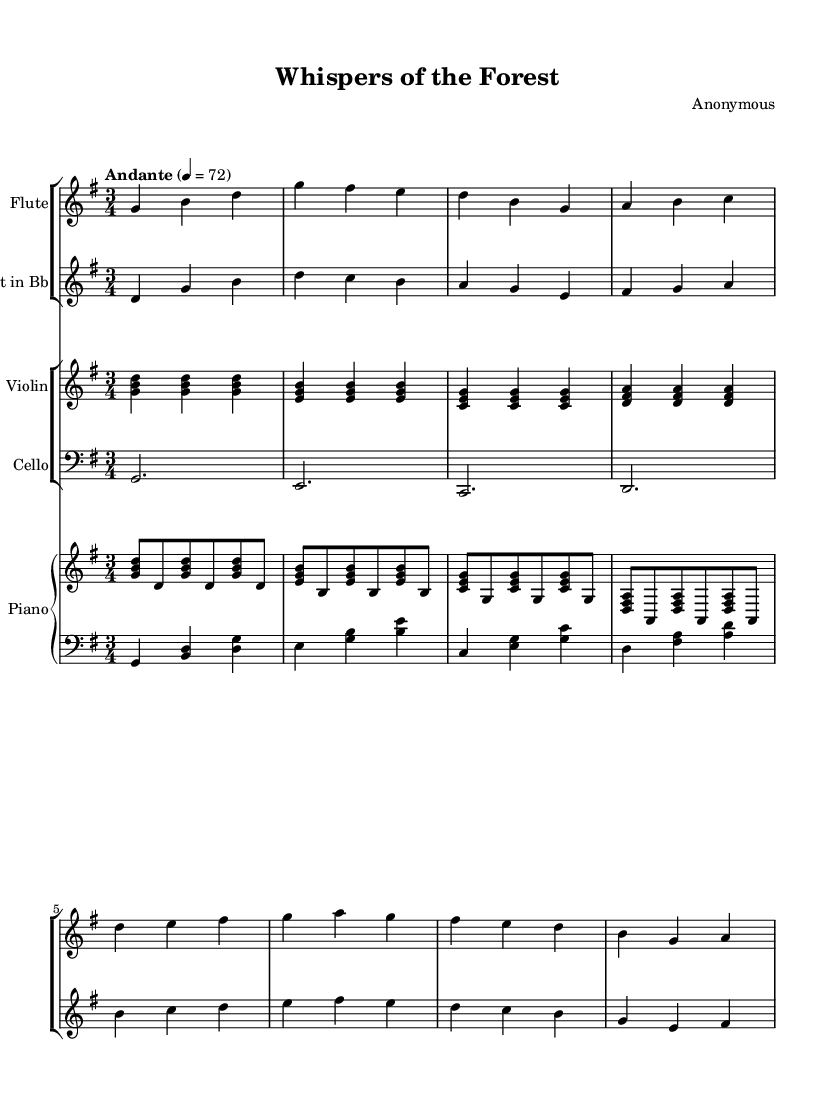What is the key signature of this music? The key signature is G major, which has one sharp (F#). This can be determined from the key signature indicated at the beginning of the piece.
Answer: G major What is the time signature of this music? The time signature is 3/4, as indicated at the beginning of the score. This means there are three beats in each measure, and the quarter note gets one beat.
Answer: 3/4 What is the tempo marking for this composition? The tempo marking is Andante, which suggests a moderate pace. This can be found in the tempo indication provided at the start of the piece.
Answer: Andante Which instrument is transposed in this music? The clarinet is transposed in this piece, as indicated by the transposition sign beside the staff. It is written in B-flat, meaning it sounds a whole step lower than written.
Answer: Clarinet How many measures are there in the flute part? The flute part has eight measures, which can be counted visually by looking at the notation. Each distinct grouping of notation separated by vertical lines represents a measure.
Answer: Eight What is the lowest note played by the cello? The lowest note played by the cello is C, which can be found at the start of the cello part when it is notated.
Answer: C Which section of instruments plays in a staff group together? The flute and clarinet play in a staff group together, as denoted by the grouping of their staves in the score.
Answer: Flute and clarinet 